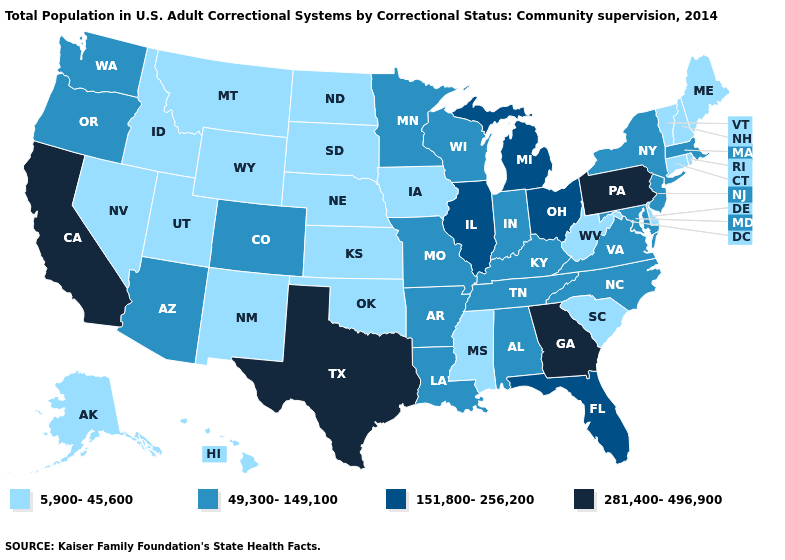Which states have the lowest value in the South?
Be succinct. Delaware, Mississippi, Oklahoma, South Carolina, West Virginia. Does Montana have the highest value in the USA?
Keep it brief. No. Does Oklahoma have the lowest value in the USA?
Give a very brief answer. Yes. Does the first symbol in the legend represent the smallest category?
Answer briefly. Yes. Name the states that have a value in the range 49,300-149,100?
Quick response, please. Alabama, Arizona, Arkansas, Colorado, Indiana, Kentucky, Louisiana, Maryland, Massachusetts, Minnesota, Missouri, New Jersey, New York, North Carolina, Oregon, Tennessee, Virginia, Washington, Wisconsin. What is the highest value in the MidWest ?
Quick response, please. 151,800-256,200. Which states have the lowest value in the USA?
Give a very brief answer. Alaska, Connecticut, Delaware, Hawaii, Idaho, Iowa, Kansas, Maine, Mississippi, Montana, Nebraska, Nevada, New Hampshire, New Mexico, North Dakota, Oklahoma, Rhode Island, South Carolina, South Dakota, Utah, Vermont, West Virginia, Wyoming. Among the states that border Virginia , does West Virginia have the highest value?
Give a very brief answer. No. What is the highest value in states that border Washington?
Be succinct. 49,300-149,100. How many symbols are there in the legend?
Quick response, please. 4. What is the value of Texas?
Keep it brief. 281,400-496,900. Name the states that have a value in the range 49,300-149,100?
Quick response, please. Alabama, Arizona, Arkansas, Colorado, Indiana, Kentucky, Louisiana, Maryland, Massachusetts, Minnesota, Missouri, New Jersey, New York, North Carolina, Oregon, Tennessee, Virginia, Washington, Wisconsin. Among the states that border Oregon , does California have the lowest value?
Be succinct. No. What is the value of Oregon?
Be succinct. 49,300-149,100. What is the value of Montana?
Be succinct. 5,900-45,600. 